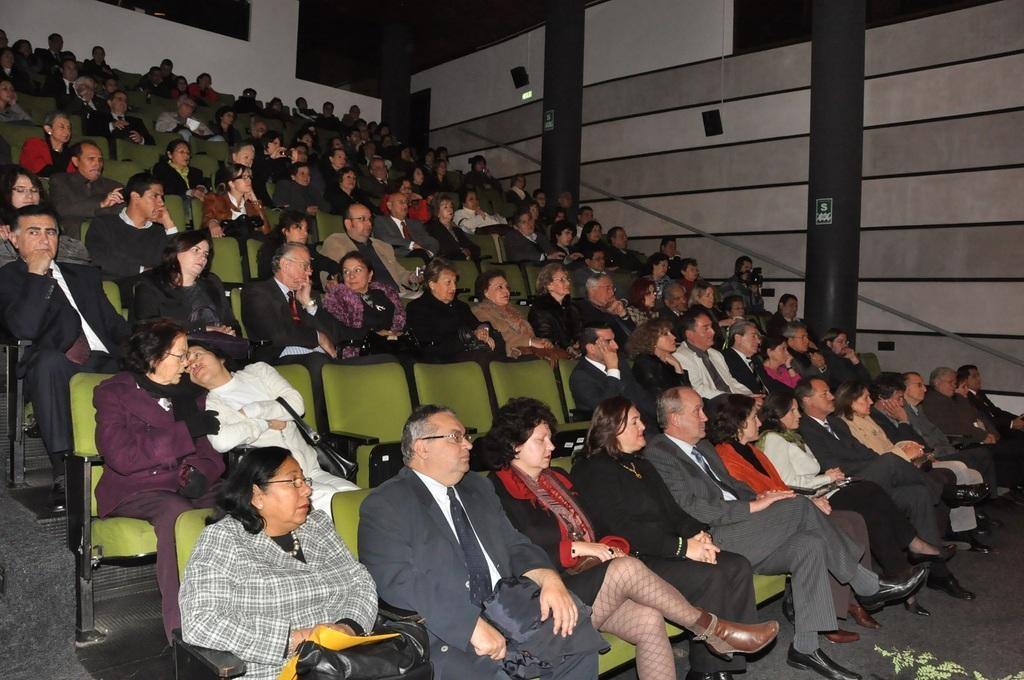What is the main subject of the image? The main subject of the image is a crowd. How are the people in the crowd positioned? The crowd is sitting on chairs. What can be seen in the background of the image? There are walls and stairs in the background of the image. What is the surface that the chairs are placed on? There is a floor visible in the image. What type of care is being provided to the cow in the image? There is no cow present in the image; it features a crowd sitting on chairs. How many cribs can be seen in the image? There are no cribs present in the image. 